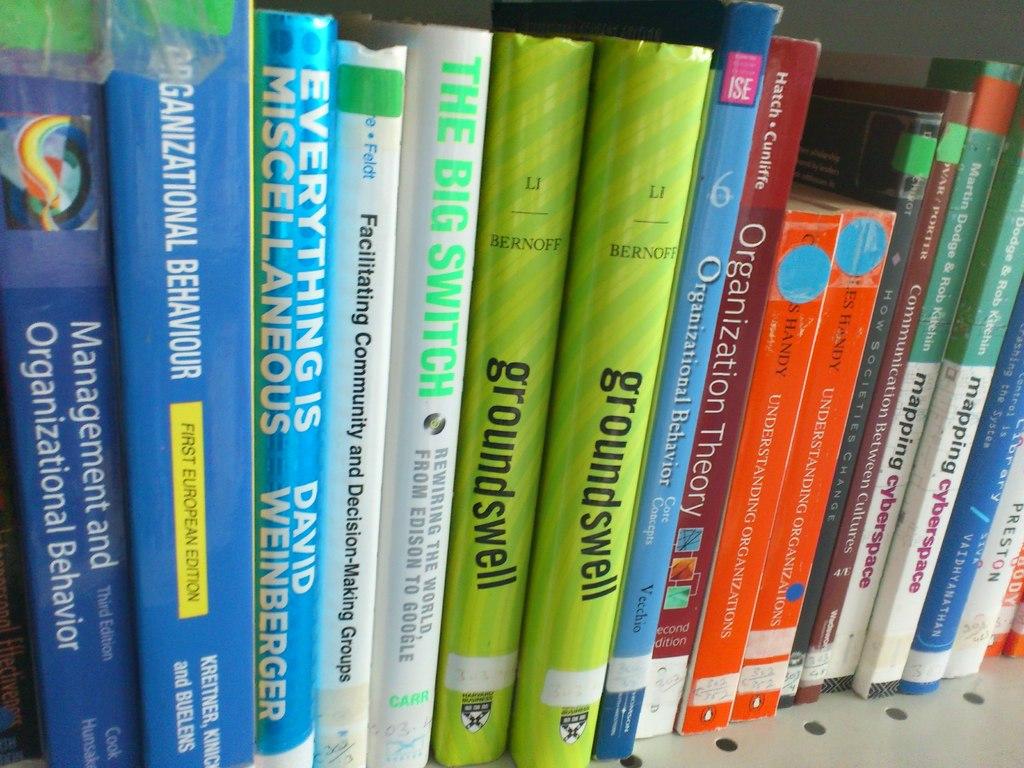What are the titles of these books?
Make the answer very short. Groundswell, management and organizational behavior, everything is miscellaneous. What is the title of the book with the green stem?
Your response must be concise. Groundswell. 